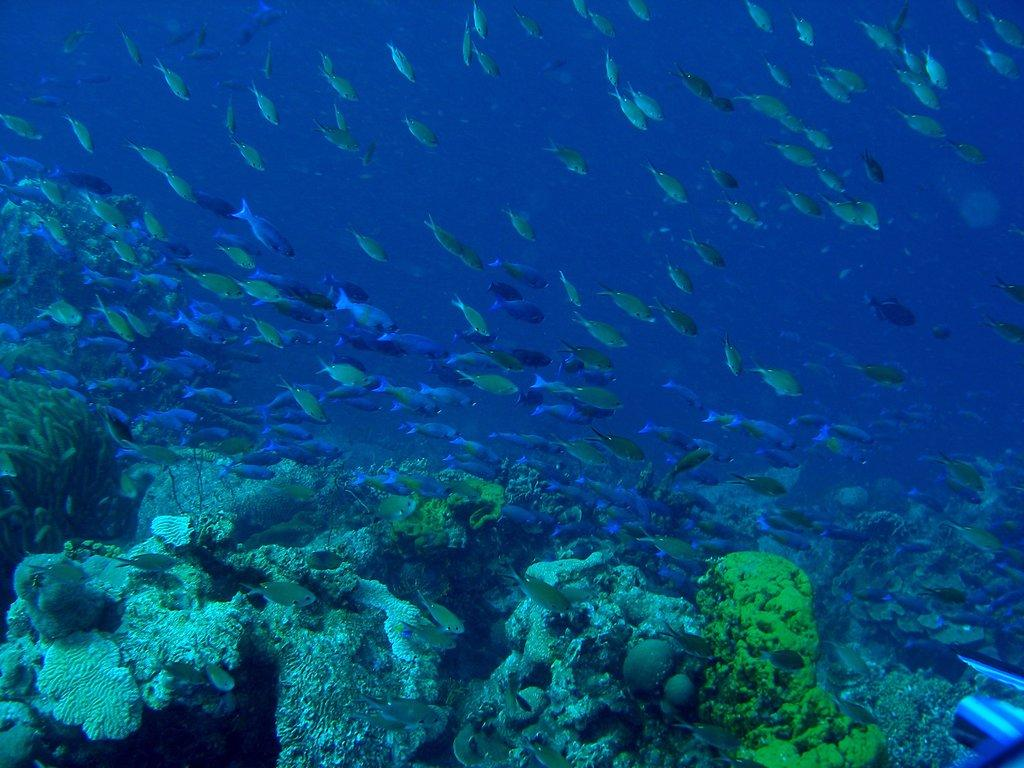What type of animals can be seen in the image? There are fishes in the image. What other elements are present in the image besides the fishes? There are plants and rocks in the image. Can you describe the object located at the bottom right corner of the image? Unfortunately, the facts provided do not give any information about the object at the bottom right corner of the image. What type of pollution is affecting the fishes in the image? There is no indication of pollution in the image; it only shows fishes, plants, and rocks. What type of meal is being prepared with the fishes in the image? There is no indication of a meal being prepared in the image; it only shows fishes, plants, and rocks. 